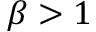<formula> <loc_0><loc_0><loc_500><loc_500>\beta > 1</formula> 